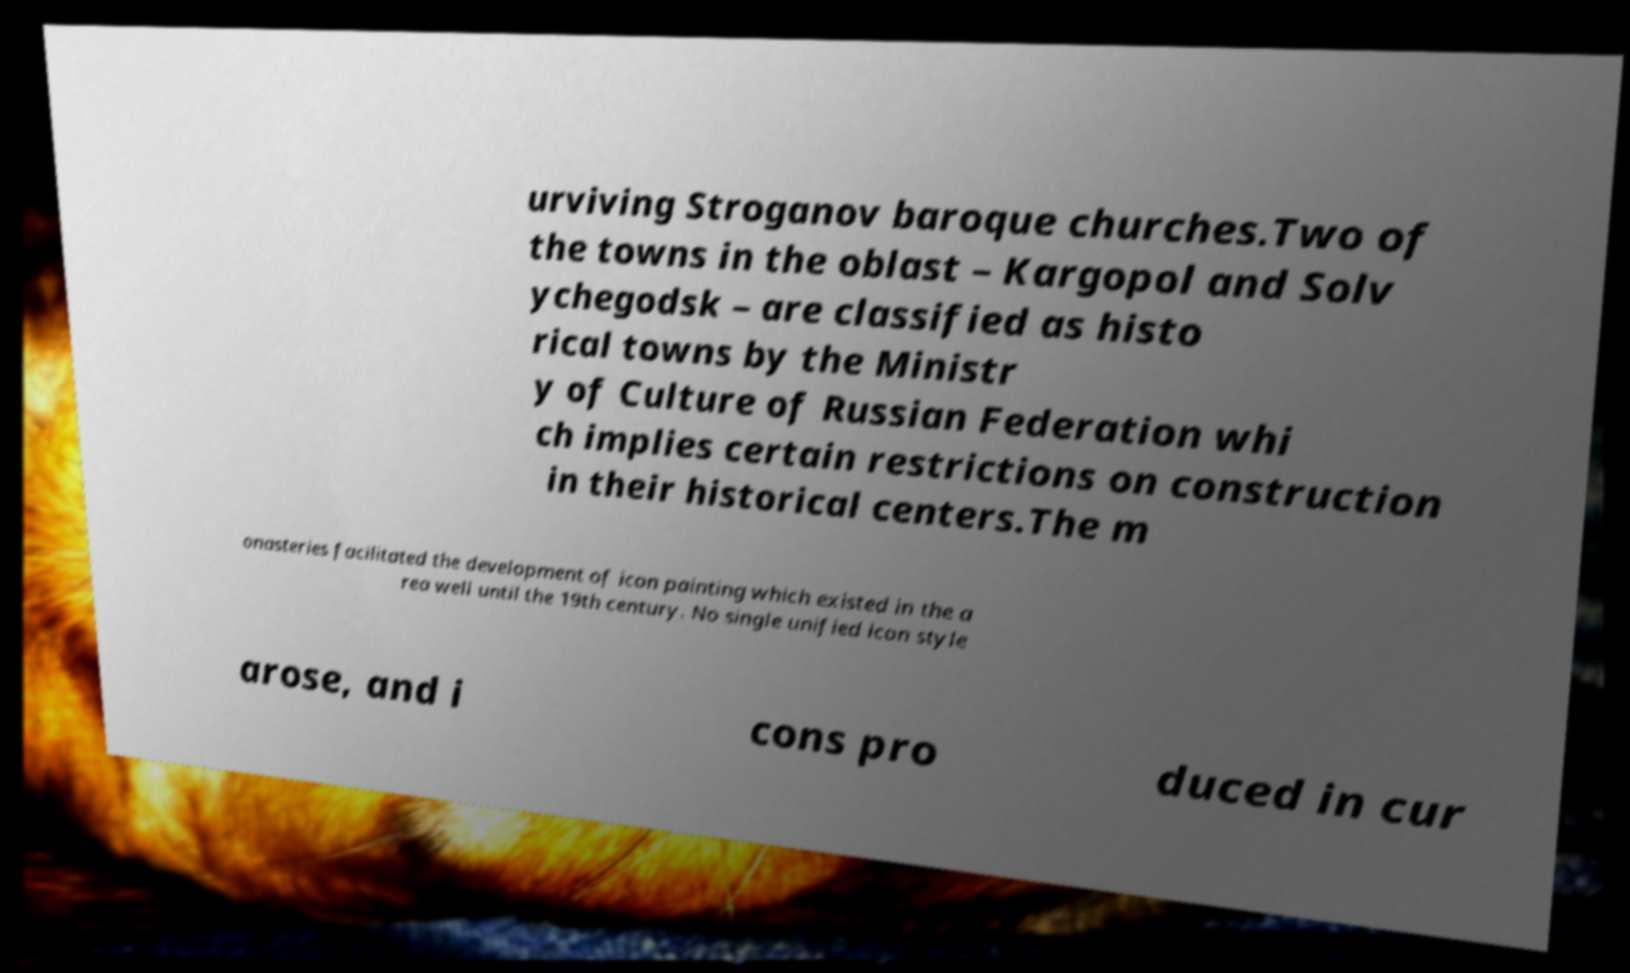I need the written content from this picture converted into text. Can you do that? urviving Stroganov baroque churches.Two of the towns in the oblast – Kargopol and Solv ychegodsk – are classified as histo rical towns by the Ministr y of Culture of Russian Federation whi ch implies certain restrictions on construction in their historical centers.The m onasteries facilitated the development of icon painting which existed in the a rea well until the 19th century. No single unified icon style arose, and i cons pro duced in cur 